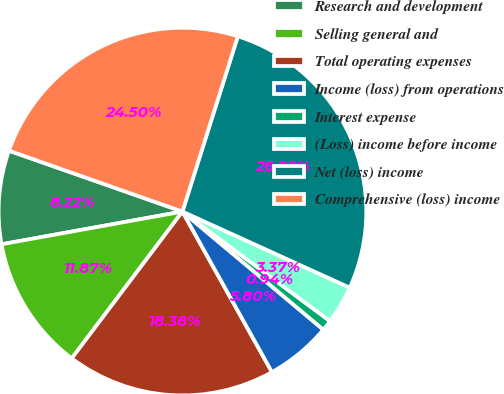<chart> <loc_0><loc_0><loc_500><loc_500><pie_chart><fcel>Research and development<fcel>Selling general and<fcel>Total operating expenses<fcel>Income (loss) from operations<fcel>Interest expense<fcel>(Loss) income before income<fcel>Net (loss) income<fcel>Comprehensive (loss) income<nl><fcel>8.22%<fcel>11.87%<fcel>18.38%<fcel>5.8%<fcel>0.94%<fcel>3.37%<fcel>26.92%<fcel>24.5%<nl></chart> 